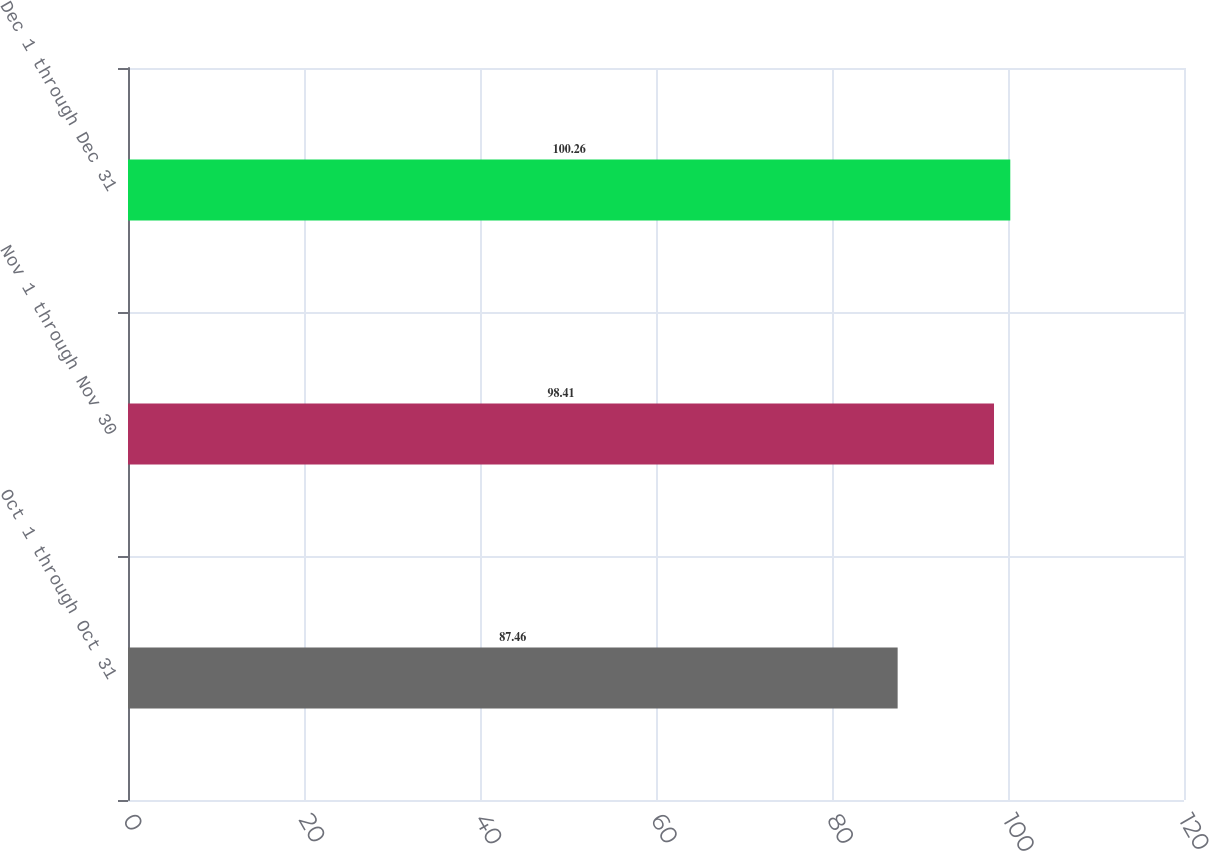Convert chart. <chart><loc_0><loc_0><loc_500><loc_500><bar_chart><fcel>Oct 1 through Oct 31<fcel>Nov 1 through Nov 30<fcel>Dec 1 through Dec 31<nl><fcel>87.46<fcel>98.41<fcel>100.26<nl></chart> 